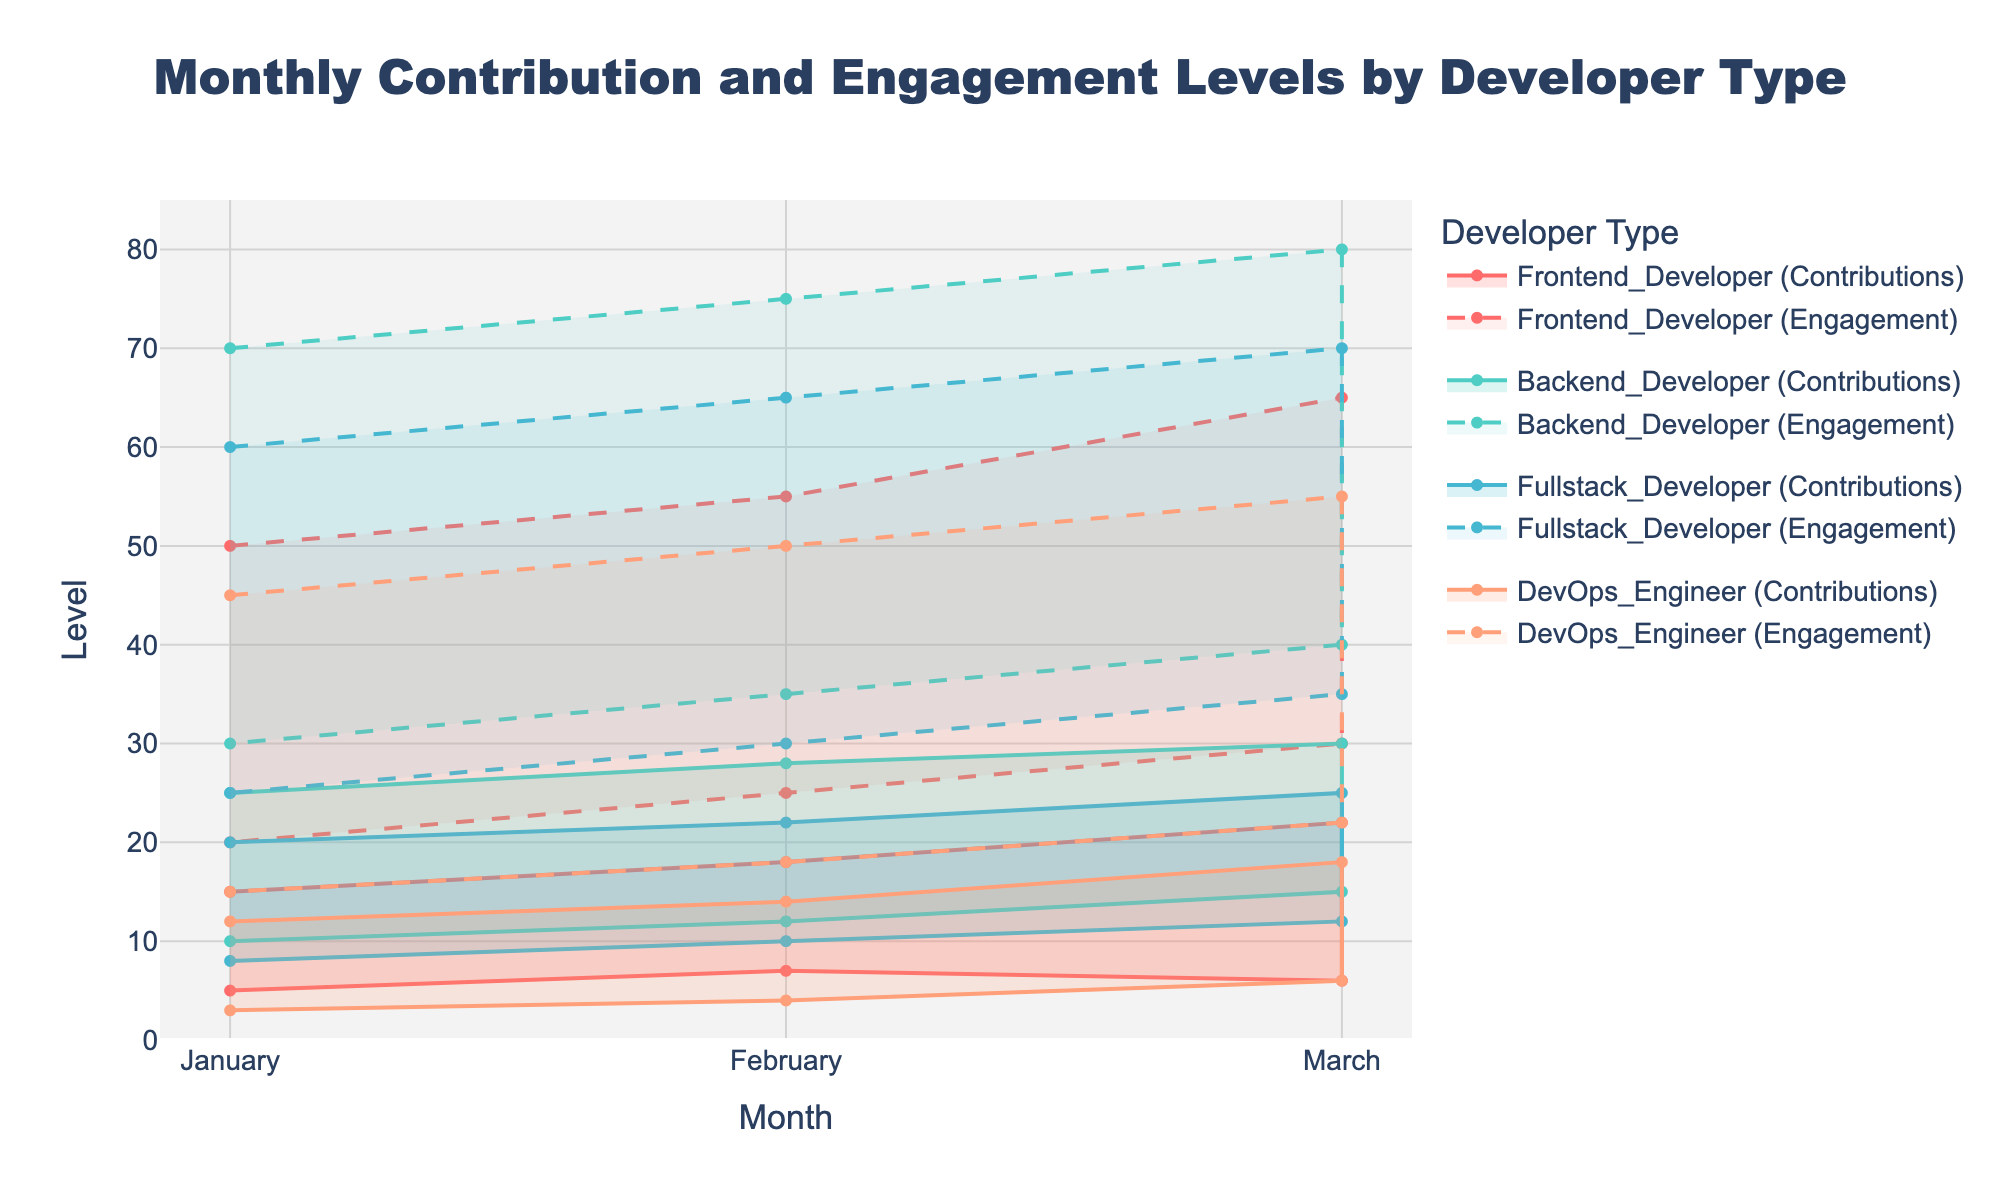What are the months depicted on the x-axis? The x-axis displays months, regarding the time frame of the data collected. These months are January, February, and March.
Answer: January, February, March Which developer type has the highest maximum contributions in March? To find this, observe the maximum contribution ranges for all developer types in March. Backend Developers have a maximum contribution of 30, which is higher than the other developer types.
Answer: Backend Developer In February, what is the minimum engagement level for DevOps Engineers? To determine this, look for the engagement range of DevOps Engineers in February. The minimum engagement level indicated is 18.
Answer: 18 What is the average maximum engagement level for Fullstack Developers over the three months? To find the average, add the maximum engagement levels for January (60), February (65), and March (70), then divide by 3. (60 + 65 + 70) / 3 = 65
Answer: 65 How does the contribution range for Frontend Developers in January compare to that in February? In January, the contributions range from 5 to 15. In February, they range from 7 to 18. February's range is both higher and wider compared to January.
Answer: February has a higher and wider range Which developer type shows the least variation in engagement levels in March? Look at the difference between the maximum and minimum engagement levels in March for each developer type. DevOps Engineers have an engagement range of 22-55, a difference of 33, which is the smallest among the types.
Answer: DevOps Engineer Between Backend Developers and Fullstack Developers, who has a higher minimum contribution in February? The minimum contributions in February for Backend and Fullstack Developers are 12 and 10, respectively. Backend Developers have a higher minimum contribution.
Answer: Backend Developer Which developer type has the maximum engagement level of 70 in any month? Search for the engagement level of 70 in any month. It is found in Backend Developers in January, which is their maximum engagement.
Answer: Backend Developer In March, what is the maximum contribution difference between any two developer types? To find this, take the maximum contribution values in March: Backend Developers (30), Frontend Developers (22), Fullstack Developers (25), DevOps Engineers (18). The maximum difference is between Backend Developers and DevOps Engineers, which is 30 - 18 = 12.
Answer: 12 